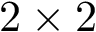<formula> <loc_0><loc_0><loc_500><loc_500>2 \times 2</formula> 